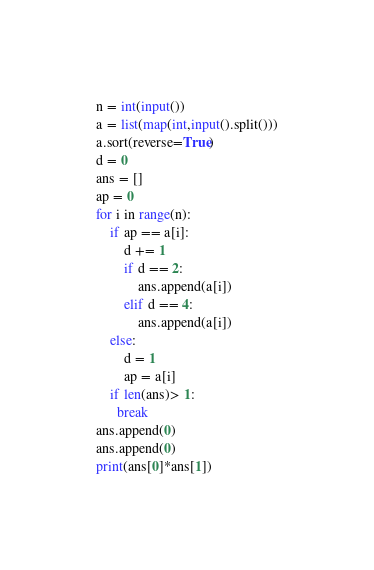<code> <loc_0><loc_0><loc_500><loc_500><_Python_>n = int(input())
a = list(map(int,input().split()))
a.sort(reverse=True)
d = 0
ans = []
ap = 0
for i in range(n):
    if ap == a[i]:
        d += 1
        if d == 2:
            ans.append(a[i])
        elif d == 4:
            ans.append(a[i])
    else:
        d = 1
        ap = a[i]    
    if len(ans)> 1:
      break
ans.append(0)
ans.append(0)
print(ans[0]*ans[1])</code> 